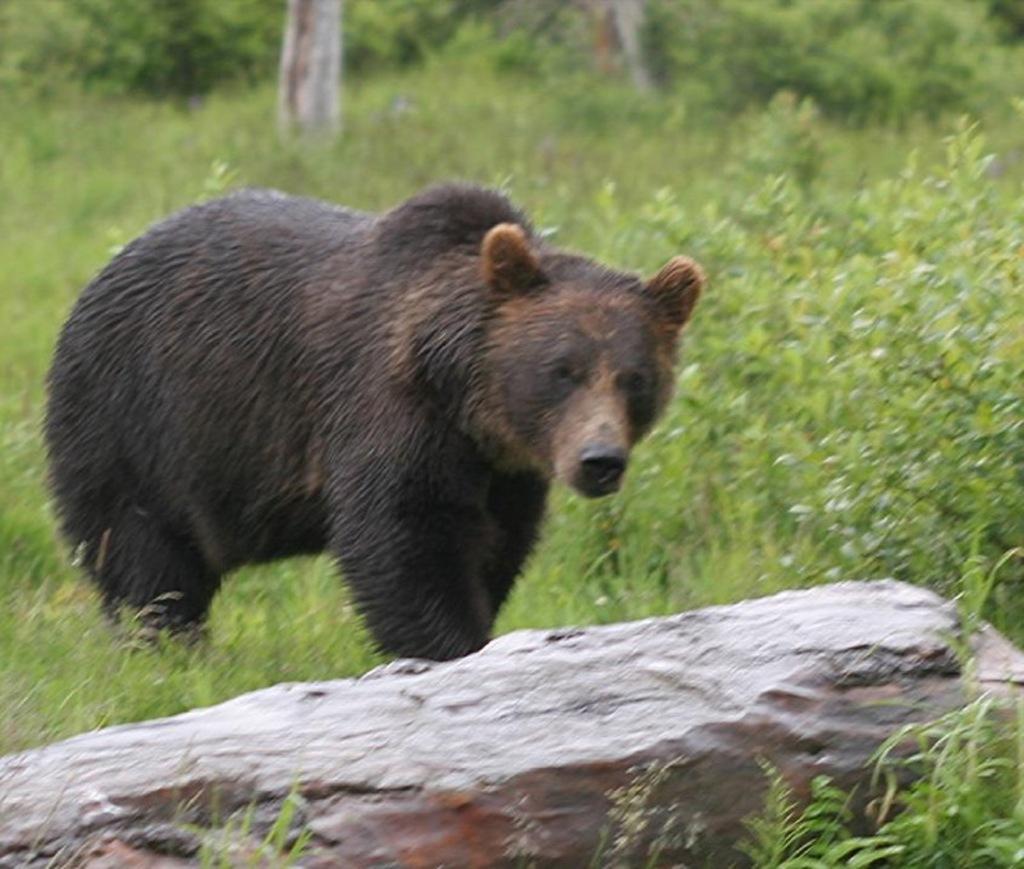How would you summarize this image in a sentence or two? It is a bear in brown color, at the bottom it is the stone, there are trees at the back side of an image. 